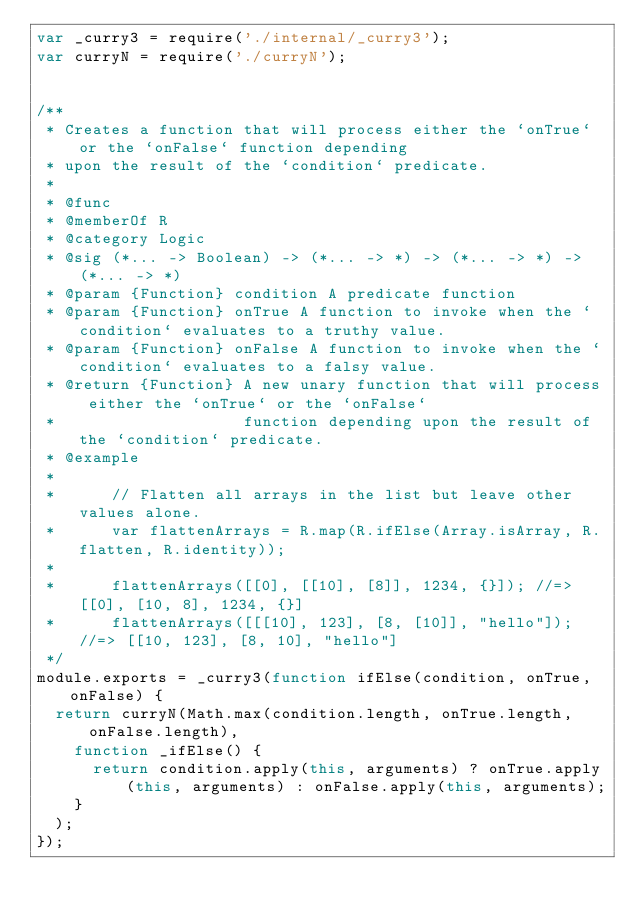<code> <loc_0><loc_0><loc_500><loc_500><_JavaScript_>var _curry3 = require('./internal/_curry3');
var curryN = require('./curryN');


/**
 * Creates a function that will process either the `onTrue` or the `onFalse` function depending
 * upon the result of the `condition` predicate.
 *
 * @func
 * @memberOf R
 * @category Logic
 * @sig (*... -> Boolean) -> (*... -> *) -> (*... -> *) -> (*... -> *)
 * @param {Function} condition A predicate function
 * @param {Function} onTrue A function to invoke when the `condition` evaluates to a truthy value.
 * @param {Function} onFalse A function to invoke when the `condition` evaluates to a falsy value.
 * @return {Function} A new unary function that will process either the `onTrue` or the `onFalse`
 *                    function depending upon the result of the `condition` predicate.
 * @example
 *
 *      // Flatten all arrays in the list but leave other values alone.
 *      var flattenArrays = R.map(R.ifElse(Array.isArray, R.flatten, R.identity));
 *
 *      flattenArrays([[0], [[10], [8]], 1234, {}]); //=> [[0], [10, 8], 1234, {}]
 *      flattenArrays([[[10], 123], [8, [10]], "hello"]); //=> [[10, 123], [8, 10], "hello"]
 */
module.exports = _curry3(function ifElse(condition, onTrue, onFalse) {
  return curryN(Math.max(condition.length, onTrue.length, onFalse.length),
    function _ifElse() {
      return condition.apply(this, arguments) ? onTrue.apply(this, arguments) : onFalse.apply(this, arguments);
    }
  );
});
</code> 